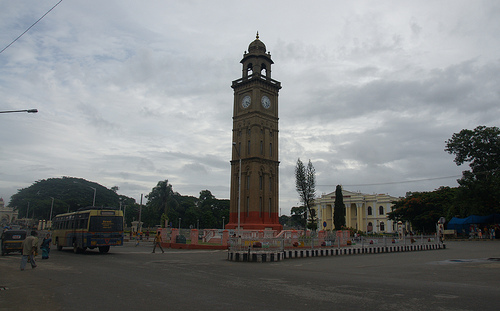How many palm trees are in the picture? There are no palm trees visible in the image. It features a clock tower set against a relatively cloudy sky in an urban setting, with no palm trees in the immediate vicinity. 